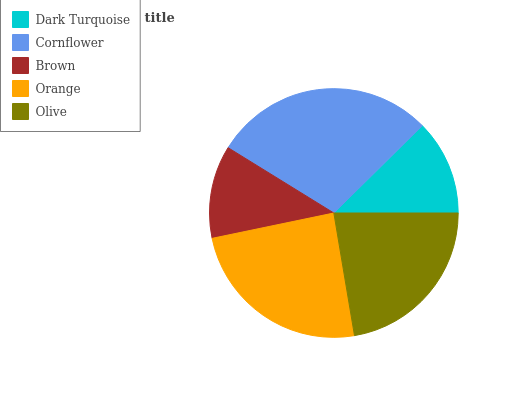Is Brown the minimum?
Answer yes or no. Yes. Is Cornflower the maximum?
Answer yes or no. Yes. Is Cornflower the minimum?
Answer yes or no. No. Is Brown the maximum?
Answer yes or no. No. Is Cornflower greater than Brown?
Answer yes or no. Yes. Is Brown less than Cornflower?
Answer yes or no. Yes. Is Brown greater than Cornflower?
Answer yes or no. No. Is Cornflower less than Brown?
Answer yes or no. No. Is Olive the high median?
Answer yes or no. Yes. Is Olive the low median?
Answer yes or no. Yes. Is Orange the high median?
Answer yes or no. No. Is Orange the low median?
Answer yes or no. No. 